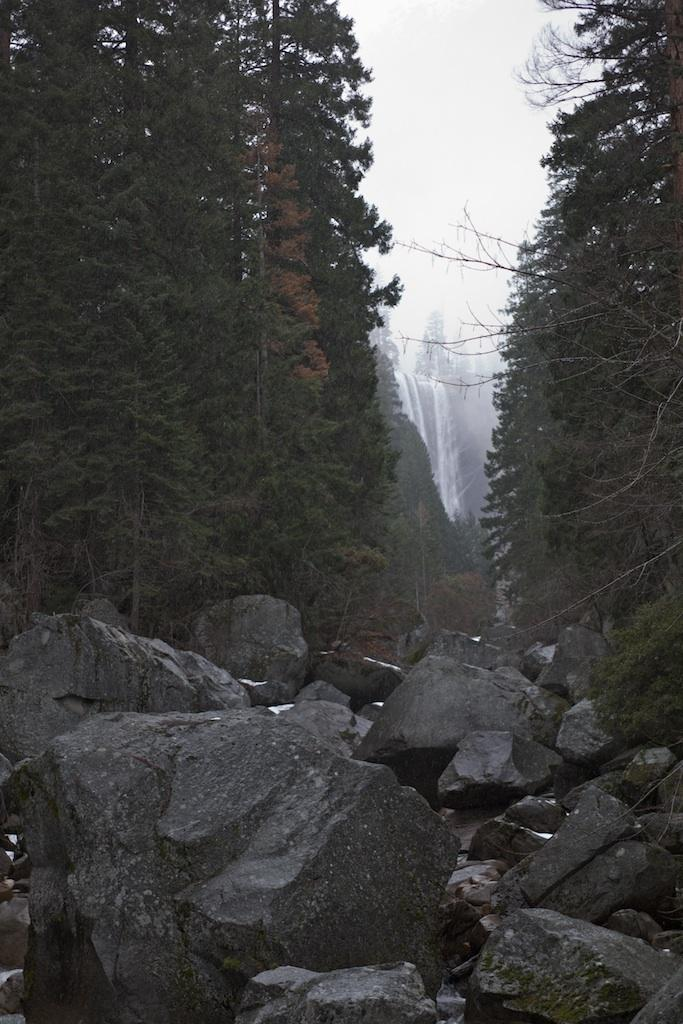What type of natural features can be seen in the image? There are trees and a waterfall in the image. What other objects can be found in the image? There are rocks in the image. How would you describe the sky in the image? The sky is cloudy in the image. What time is displayed on the clock in the image? There is no clock present in the image. What arithmetic problem is being solved by the visitor in the image? There is no visitor or arithmetic problem present in the image. 